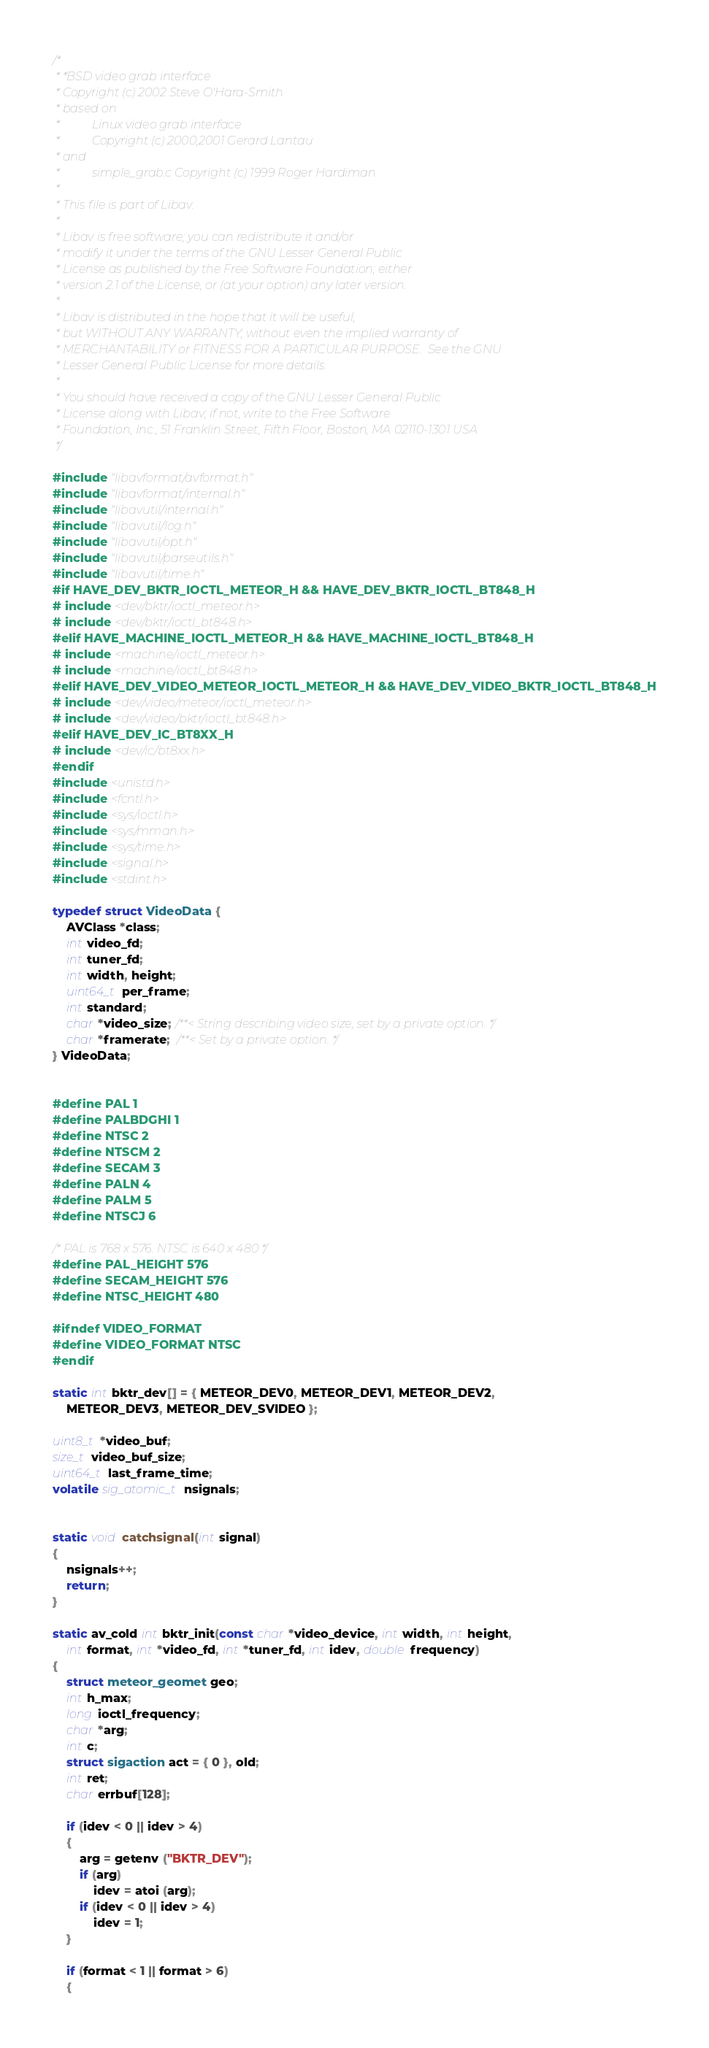<code> <loc_0><loc_0><loc_500><loc_500><_C_>/*
 * *BSD video grab interface
 * Copyright (c) 2002 Steve O'Hara-Smith
 * based on
 *           Linux video grab interface
 *           Copyright (c) 2000,2001 Gerard Lantau
 * and
 *           simple_grab.c Copyright (c) 1999 Roger Hardiman
 *
 * This file is part of Libav.
 *
 * Libav is free software; you can redistribute it and/or
 * modify it under the terms of the GNU Lesser General Public
 * License as published by the Free Software Foundation; either
 * version 2.1 of the License, or (at your option) any later version.
 *
 * Libav is distributed in the hope that it will be useful,
 * but WITHOUT ANY WARRANTY; without even the implied warranty of
 * MERCHANTABILITY or FITNESS FOR A PARTICULAR PURPOSE.  See the GNU
 * Lesser General Public License for more details.
 *
 * You should have received a copy of the GNU Lesser General Public
 * License along with Libav; if not, write to the Free Software
 * Foundation, Inc., 51 Franklin Street, Fifth Floor, Boston, MA 02110-1301 USA
 */

#include "libavformat/avformat.h"
#include "libavformat/internal.h"
#include "libavutil/internal.h"
#include "libavutil/log.h"
#include "libavutil/opt.h"
#include "libavutil/parseutils.h"
#include "libavutil/time.h"
#if HAVE_DEV_BKTR_IOCTL_METEOR_H && HAVE_DEV_BKTR_IOCTL_BT848_H
# include <dev/bktr/ioctl_meteor.h>
# include <dev/bktr/ioctl_bt848.h>
#elif HAVE_MACHINE_IOCTL_METEOR_H && HAVE_MACHINE_IOCTL_BT848_H
# include <machine/ioctl_meteor.h>
# include <machine/ioctl_bt848.h>
#elif HAVE_DEV_VIDEO_METEOR_IOCTL_METEOR_H && HAVE_DEV_VIDEO_BKTR_IOCTL_BT848_H
# include <dev/video/meteor/ioctl_meteor.h>
# include <dev/video/bktr/ioctl_bt848.h>
#elif HAVE_DEV_IC_BT8XX_H
# include <dev/ic/bt8xx.h>
#endif
#include <unistd.h>
#include <fcntl.h>
#include <sys/ioctl.h>
#include <sys/mman.h>
#include <sys/time.h>
#include <signal.h>
#include <stdint.h>

typedef struct VideoData {
    AVClass *class;
    int video_fd;
    int tuner_fd;
    int width, height;
    uint64_t per_frame;
    int standard;
    char *video_size; /**< String describing video size, set by a private option. */
    char *framerate;  /**< Set by a private option. */
} VideoData;


#define PAL 1
#define PALBDGHI 1
#define NTSC 2
#define NTSCM 2
#define SECAM 3
#define PALN 4
#define PALM 5
#define NTSCJ 6

/* PAL is 768 x 576. NTSC is 640 x 480 */
#define PAL_HEIGHT 576
#define SECAM_HEIGHT 576
#define NTSC_HEIGHT 480

#ifndef VIDEO_FORMAT
#define VIDEO_FORMAT NTSC
#endif

static int bktr_dev[] = { METEOR_DEV0, METEOR_DEV1, METEOR_DEV2,
    METEOR_DEV3, METEOR_DEV_SVIDEO };

uint8_t *video_buf;
size_t video_buf_size;
uint64_t last_frame_time;
volatile sig_atomic_t nsignals;


static void catchsignal(int signal)
{
    nsignals++;
    return;
}

static av_cold int bktr_init(const char *video_device, int width, int height,
    int format, int *video_fd, int *tuner_fd, int idev, double frequency)
{
    struct meteor_geomet geo;
    int h_max;
    long ioctl_frequency;
    char *arg;
    int c;
    struct sigaction act = { 0 }, old;
    int ret;
    char errbuf[128];

    if (idev < 0 || idev > 4)
    {
        arg = getenv ("BKTR_DEV");
        if (arg)
            idev = atoi (arg);
        if (idev < 0 || idev > 4)
            idev = 1;
    }

    if (format < 1 || format > 6)
    {</code> 